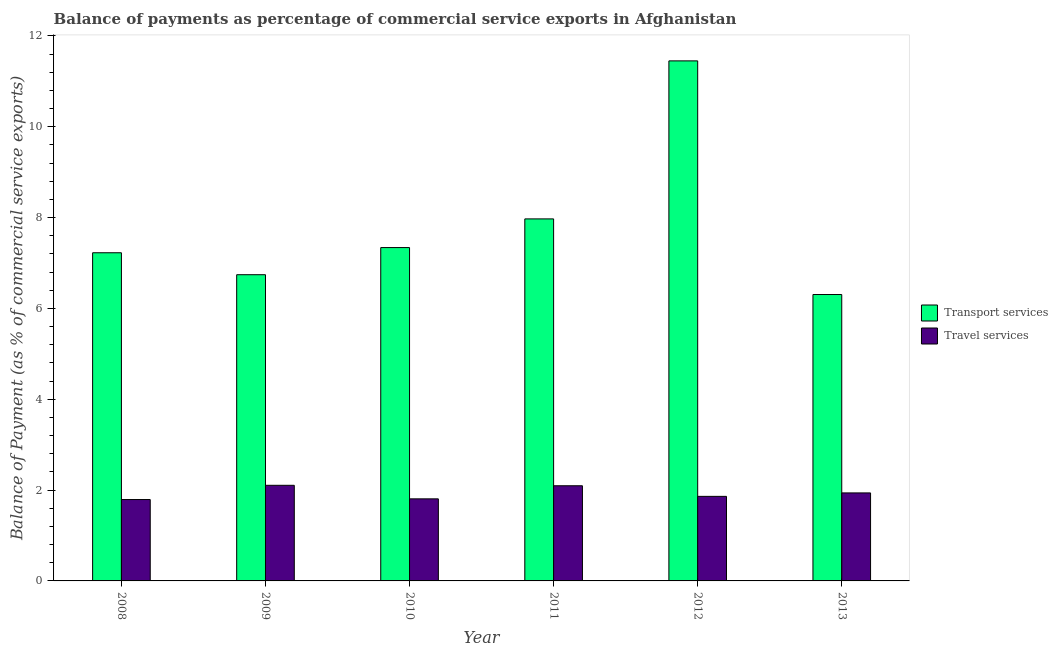How many different coloured bars are there?
Make the answer very short. 2. Are the number of bars per tick equal to the number of legend labels?
Make the answer very short. Yes. What is the balance of payments of transport services in 2008?
Your answer should be compact. 7.23. Across all years, what is the maximum balance of payments of travel services?
Your answer should be compact. 2.11. Across all years, what is the minimum balance of payments of travel services?
Make the answer very short. 1.79. In which year was the balance of payments of transport services minimum?
Keep it short and to the point. 2013. What is the total balance of payments of transport services in the graph?
Provide a short and direct response. 47.03. What is the difference between the balance of payments of transport services in 2008 and that in 2010?
Offer a terse response. -0.11. What is the difference between the balance of payments of transport services in 2011 and the balance of payments of travel services in 2009?
Provide a short and direct response. 1.23. What is the average balance of payments of transport services per year?
Keep it short and to the point. 7.84. What is the ratio of the balance of payments of travel services in 2008 to that in 2012?
Offer a terse response. 0.96. What is the difference between the highest and the second highest balance of payments of transport services?
Keep it short and to the point. 3.48. What is the difference between the highest and the lowest balance of payments of travel services?
Keep it short and to the point. 0.31. Is the sum of the balance of payments of transport services in 2008 and 2013 greater than the maximum balance of payments of travel services across all years?
Your answer should be very brief. Yes. What does the 1st bar from the left in 2010 represents?
Provide a succinct answer. Transport services. What does the 2nd bar from the right in 2013 represents?
Ensure brevity in your answer.  Transport services. Are all the bars in the graph horizontal?
Keep it short and to the point. No. How many years are there in the graph?
Ensure brevity in your answer.  6. What is the difference between two consecutive major ticks on the Y-axis?
Offer a very short reply. 2. Are the values on the major ticks of Y-axis written in scientific E-notation?
Offer a terse response. No. Where does the legend appear in the graph?
Give a very brief answer. Center right. What is the title of the graph?
Your response must be concise. Balance of payments as percentage of commercial service exports in Afghanistan. Does "Highest 20% of population" appear as one of the legend labels in the graph?
Provide a short and direct response. No. What is the label or title of the X-axis?
Give a very brief answer. Year. What is the label or title of the Y-axis?
Provide a succinct answer. Balance of Payment (as % of commercial service exports). What is the Balance of Payment (as % of commercial service exports) in Transport services in 2008?
Make the answer very short. 7.23. What is the Balance of Payment (as % of commercial service exports) in Travel services in 2008?
Offer a very short reply. 1.79. What is the Balance of Payment (as % of commercial service exports) of Transport services in 2009?
Your answer should be compact. 6.74. What is the Balance of Payment (as % of commercial service exports) of Travel services in 2009?
Ensure brevity in your answer.  2.11. What is the Balance of Payment (as % of commercial service exports) of Transport services in 2010?
Offer a terse response. 7.34. What is the Balance of Payment (as % of commercial service exports) of Travel services in 2010?
Ensure brevity in your answer.  1.81. What is the Balance of Payment (as % of commercial service exports) in Transport services in 2011?
Give a very brief answer. 7.97. What is the Balance of Payment (as % of commercial service exports) of Travel services in 2011?
Make the answer very short. 2.1. What is the Balance of Payment (as % of commercial service exports) of Transport services in 2012?
Keep it short and to the point. 11.45. What is the Balance of Payment (as % of commercial service exports) in Travel services in 2012?
Your answer should be compact. 1.86. What is the Balance of Payment (as % of commercial service exports) of Transport services in 2013?
Give a very brief answer. 6.31. What is the Balance of Payment (as % of commercial service exports) of Travel services in 2013?
Your answer should be compact. 1.94. Across all years, what is the maximum Balance of Payment (as % of commercial service exports) of Transport services?
Keep it short and to the point. 11.45. Across all years, what is the maximum Balance of Payment (as % of commercial service exports) in Travel services?
Offer a very short reply. 2.11. Across all years, what is the minimum Balance of Payment (as % of commercial service exports) of Transport services?
Your response must be concise. 6.31. Across all years, what is the minimum Balance of Payment (as % of commercial service exports) in Travel services?
Give a very brief answer. 1.79. What is the total Balance of Payment (as % of commercial service exports) of Transport services in the graph?
Provide a short and direct response. 47.03. What is the total Balance of Payment (as % of commercial service exports) of Travel services in the graph?
Your answer should be very brief. 11.6. What is the difference between the Balance of Payment (as % of commercial service exports) of Transport services in 2008 and that in 2009?
Provide a succinct answer. 0.48. What is the difference between the Balance of Payment (as % of commercial service exports) in Travel services in 2008 and that in 2009?
Ensure brevity in your answer.  -0.31. What is the difference between the Balance of Payment (as % of commercial service exports) in Transport services in 2008 and that in 2010?
Make the answer very short. -0.11. What is the difference between the Balance of Payment (as % of commercial service exports) of Travel services in 2008 and that in 2010?
Ensure brevity in your answer.  -0.02. What is the difference between the Balance of Payment (as % of commercial service exports) in Transport services in 2008 and that in 2011?
Your answer should be compact. -0.75. What is the difference between the Balance of Payment (as % of commercial service exports) in Travel services in 2008 and that in 2011?
Ensure brevity in your answer.  -0.3. What is the difference between the Balance of Payment (as % of commercial service exports) of Transport services in 2008 and that in 2012?
Your answer should be very brief. -4.23. What is the difference between the Balance of Payment (as % of commercial service exports) of Travel services in 2008 and that in 2012?
Ensure brevity in your answer.  -0.07. What is the difference between the Balance of Payment (as % of commercial service exports) of Transport services in 2008 and that in 2013?
Ensure brevity in your answer.  0.92. What is the difference between the Balance of Payment (as % of commercial service exports) in Travel services in 2008 and that in 2013?
Ensure brevity in your answer.  -0.15. What is the difference between the Balance of Payment (as % of commercial service exports) in Transport services in 2009 and that in 2010?
Provide a succinct answer. -0.6. What is the difference between the Balance of Payment (as % of commercial service exports) in Travel services in 2009 and that in 2010?
Offer a very short reply. 0.3. What is the difference between the Balance of Payment (as % of commercial service exports) in Transport services in 2009 and that in 2011?
Your answer should be compact. -1.23. What is the difference between the Balance of Payment (as % of commercial service exports) in Travel services in 2009 and that in 2011?
Keep it short and to the point. 0.01. What is the difference between the Balance of Payment (as % of commercial service exports) of Transport services in 2009 and that in 2012?
Give a very brief answer. -4.71. What is the difference between the Balance of Payment (as % of commercial service exports) in Travel services in 2009 and that in 2012?
Your answer should be compact. 0.24. What is the difference between the Balance of Payment (as % of commercial service exports) of Transport services in 2009 and that in 2013?
Your answer should be compact. 0.44. What is the difference between the Balance of Payment (as % of commercial service exports) of Travel services in 2009 and that in 2013?
Provide a short and direct response. 0.17. What is the difference between the Balance of Payment (as % of commercial service exports) of Transport services in 2010 and that in 2011?
Provide a short and direct response. -0.63. What is the difference between the Balance of Payment (as % of commercial service exports) in Travel services in 2010 and that in 2011?
Your answer should be very brief. -0.29. What is the difference between the Balance of Payment (as % of commercial service exports) in Transport services in 2010 and that in 2012?
Ensure brevity in your answer.  -4.11. What is the difference between the Balance of Payment (as % of commercial service exports) of Travel services in 2010 and that in 2012?
Your response must be concise. -0.05. What is the difference between the Balance of Payment (as % of commercial service exports) in Transport services in 2010 and that in 2013?
Your answer should be very brief. 1.03. What is the difference between the Balance of Payment (as % of commercial service exports) in Travel services in 2010 and that in 2013?
Your response must be concise. -0.13. What is the difference between the Balance of Payment (as % of commercial service exports) of Transport services in 2011 and that in 2012?
Make the answer very short. -3.48. What is the difference between the Balance of Payment (as % of commercial service exports) of Travel services in 2011 and that in 2012?
Your answer should be very brief. 0.23. What is the difference between the Balance of Payment (as % of commercial service exports) in Transport services in 2011 and that in 2013?
Keep it short and to the point. 1.67. What is the difference between the Balance of Payment (as % of commercial service exports) of Travel services in 2011 and that in 2013?
Give a very brief answer. 0.16. What is the difference between the Balance of Payment (as % of commercial service exports) in Transport services in 2012 and that in 2013?
Offer a terse response. 5.14. What is the difference between the Balance of Payment (as % of commercial service exports) in Travel services in 2012 and that in 2013?
Provide a short and direct response. -0.08. What is the difference between the Balance of Payment (as % of commercial service exports) of Transport services in 2008 and the Balance of Payment (as % of commercial service exports) of Travel services in 2009?
Ensure brevity in your answer.  5.12. What is the difference between the Balance of Payment (as % of commercial service exports) in Transport services in 2008 and the Balance of Payment (as % of commercial service exports) in Travel services in 2010?
Your answer should be compact. 5.42. What is the difference between the Balance of Payment (as % of commercial service exports) of Transport services in 2008 and the Balance of Payment (as % of commercial service exports) of Travel services in 2011?
Your response must be concise. 5.13. What is the difference between the Balance of Payment (as % of commercial service exports) in Transport services in 2008 and the Balance of Payment (as % of commercial service exports) in Travel services in 2012?
Your response must be concise. 5.36. What is the difference between the Balance of Payment (as % of commercial service exports) of Transport services in 2008 and the Balance of Payment (as % of commercial service exports) of Travel services in 2013?
Ensure brevity in your answer.  5.29. What is the difference between the Balance of Payment (as % of commercial service exports) in Transport services in 2009 and the Balance of Payment (as % of commercial service exports) in Travel services in 2010?
Give a very brief answer. 4.93. What is the difference between the Balance of Payment (as % of commercial service exports) of Transport services in 2009 and the Balance of Payment (as % of commercial service exports) of Travel services in 2011?
Your answer should be very brief. 4.65. What is the difference between the Balance of Payment (as % of commercial service exports) of Transport services in 2009 and the Balance of Payment (as % of commercial service exports) of Travel services in 2012?
Your response must be concise. 4.88. What is the difference between the Balance of Payment (as % of commercial service exports) in Transport services in 2009 and the Balance of Payment (as % of commercial service exports) in Travel services in 2013?
Provide a short and direct response. 4.8. What is the difference between the Balance of Payment (as % of commercial service exports) of Transport services in 2010 and the Balance of Payment (as % of commercial service exports) of Travel services in 2011?
Keep it short and to the point. 5.24. What is the difference between the Balance of Payment (as % of commercial service exports) of Transport services in 2010 and the Balance of Payment (as % of commercial service exports) of Travel services in 2012?
Your answer should be very brief. 5.48. What is the difference between the Balance of Payment (as % of commercial service exports) in Transport services in 2010 and the Balance of Payment (as % of commercial service exports) in Travel services in 2013?
Ensure brevity in your answer.  5.4. What is the difference between the Balance of Payment (as % of commercial service exports) in Transport services in 2011 and the Balance of Payment (as % of commercial service exports) in Travel services in 2012?
Provide a succinct answer. 6.11. What is the difference between the Balance of Payment (as % of commercial service exports) in Transport services in 2011 and the Balance of Payment (as % of commercial service exports) in Travel services in 2013?
Your answer should be compact. 6.03. What is the difference between the Balance of Payment (as % of commercial service exports) of Transport services in 2012 and the Balance of Payment (as % of commercial service exports) of Travel services in 2013?
Provide a short and direct response. 9.51. What is the average Balance of Payment (as % of commercial service exports) of Transport services per year?
Your answer should be compact. 7.84. What is the average Balance of Payment (as % of commercial service exports) in Travel services per year?
Your response must be concise. 1.93. In the year 2008, what is the difference between the Balance of Payment (as % of commercial service exports) in Transport services and Balance of Payment (as % of commercial service exports) in Travel services?
Ensure brevity in your answer.  5.43. In the year 2009, what is the difference between the Balance of Payment (as % of commercial service exports) in Transport services and Balance of Payment (as % of commercial service exports) in Travel services?
Provide a succinct answer. 4.64. In the year 2010, what is the difference between the Balance of Payment (as % of commercial service exports) of Transport services and Balance of Payment (as % of commercial service exports) of Travel services?
Provide a short and direct response. 5.53. In the year 2011, what is the difference between the Balance of Payment (as % of commercial service exports) of Transport services and Balance of Payment (as % of commercial service exports) of Travel services?
Your answer should be compact. 5.88. In the year 2012, what is the difference between the Balance of Payment (as % of commercial service exports) of Transport services and Balance of Payment (as % of commercial service exports) of Travel services?
Make the answer very short. 9.59. In the year 2013, what is the difference between the Balance of Payment (as % of commercial service exports) in Transport services and Balance of Payment (as % of commercial service exports) in Travel services?
Give a very brief answer. 4.37. What is the ratio of the Balance of Payment (as % of commercial service exports) of Transport services in 2008 to that in 2009?
Ensure brevity in your answer.  1.07. What is the ratio of the Balance of Payment (as % of commercial service exports) in Travel services in 2008 to that in 2009?
Your answer should be compact. 0.85. What is the ratio of the Balance of Payment (as % of commercial service exports) of Transport services in 2008 to that in 2010?
Keep it short and to the point. 0.98. What is the ratio of the Balance of Payment (as % of commercial service exports) of Travel services in 2008 to that in 2010?
Your response must be concise. 0.99. What is the ratio of the Balance of Payment (as % of commercial service exports) in Transport services in 2008 to that in 2011?
Provide a succinct answer. 0.91. What is the ratio of the Balance of Payment (as % of commercial service exports) in Travel services in 2008 to that in 2011?
Offer a terse response. 0.86. What is the ratio of the Balance of Payment (as % of commercial service exports) of Transport services in 2008 to that in 2012?
Provide a short and direct response. 0.63. What is the ratio of the Balance of Payment (as % of commercial service exports) in Travel services in 2008 to that in 2012?
Your answer should be compact. 0.96. What is the ratio of the Balance of Payment (as % of commercial service exports) of Transport services in 2008 to that in 2013?
Give a very brief answer. 1.15. What is the ratio of the Balance of Payment (as % of commercial service exports) of Travel services in 2008 to that in 2013?
Provide a short and direct response. 0.92. What is the ratio of the Balance of Payment (as % of commercial service exports) in Transport services in 2009 to that in 2010?
Your response must be concise. 0.92. What is the ratio of the Balance of Payment (as % of commercial service exports) of Travel services in 2009 to that in 2010?
Keep it short and to the point. 1.16. What is the ratio of the Balance of Payment (as % of commercial service exports) of Transport services in 2009 to that in 2011?
Make the answer very short. 0.85. What is the ratio of the Balance of Payment (as % of commercial service exports) of Travel services in 2009 to that in 2011?
Keep it short and to the point. 1. What is the ratio of the Balance of Payment (as % of commercial service exports) in Transport services in 2009 to that in 2012?
Offer a very short reply. 0.59. What is the ratio of the Balance of Payment (as % of commercial service exports) of Travel services in 2009 to that in 2012?
Give a very brief answer. 1.13. What is the ratio of the Balance of Payment (as % of commercial service exports) in Transport services in 2009 to that in 2013?
Offer a terse response. 1.07. What is the ratio of the Balance of Payment (as % of commercial service exports) in Travel services in 2009 to that in 2013?
Provide a short and direct response. 1.09. What is the ratio of the Balance of Payment (as % of commercial service exports) in Transport services in 2010 to that in 2011?
Make the answer very short. 0.92. What is the ratio of the Balance of Payment (as % of commercial service exports) of Travel services in 2010 to that in 2011?
Keep it short and to the point. 0.86. What is the ratio of the Balance of Payment (as % of commercial service exports) of Transport services in 2010 to that in 2012?
Make the answer very short. 0.64. What is the ratio of the Balance of Payment (as % of commercial service exports) of Travel services in 2010 to that in 2012?
Offer a very short reply. 0.97. What is the ratio of the Balance of Payment (as % of commercial service exports) of Transport services in 2010 to that in 2013?
Keep it short and to the point. 1.16. What is the ratio of the Balance of Payment (as % of commercial service exports) in Travel services in 2010 to that in 2013?
Provide a succinct answer. 0.93. What is the ratio of the Balance of Payment (as % of commercial service exports) in Transport services in 2011 to that in 2012?
Keep it short and to the point. 0.7. What is the ratio of the Balance of Payment (as % of commercial service exports) in Travel services in 2011 to that in 2012?
Your answer should be very brief. 1.13. What is the ratio of the Balance of Payment (as % of commercial service exports) in Transport services in 2011 to that in 2013?
Your answer should be very brief. 1.26. What is the ratio of the Balance of Payment (as % of commercial service exports) of Travel services in 2011 to that in 2013?
Your answer should be compact. 1.08. What is the ratio of the Balance of Payment (as % of commercial service exports) in Transport services in 2012 to that in 2013?
Ensure brevity in your answer.  1.82. What is the ratio of the Balance of Payment (as % of commercial service exports) of Travel services in 2012 to that in 2013?
Provide a succinct answer. 0.96. What is the difference between the highest and the second highest Balance of Payment (as % of commercial service exports) of Transport services?
Make the answer very short. 3.48. What is the difference between the highest and the second highest Balance of Payment (as % of commercial service exports) in Travel services?
Your answer should be compact. 0.01. What is the difference between the highest and the lowest Balance of Payment (as % of commercial service exports) in Transport services?
Your response must be concise. 5.14. What is the difference between the highest and the lowest Balance of Payment (as % of commercial service exports) of Travel services?
Provide a short and direct response. 0.31. 